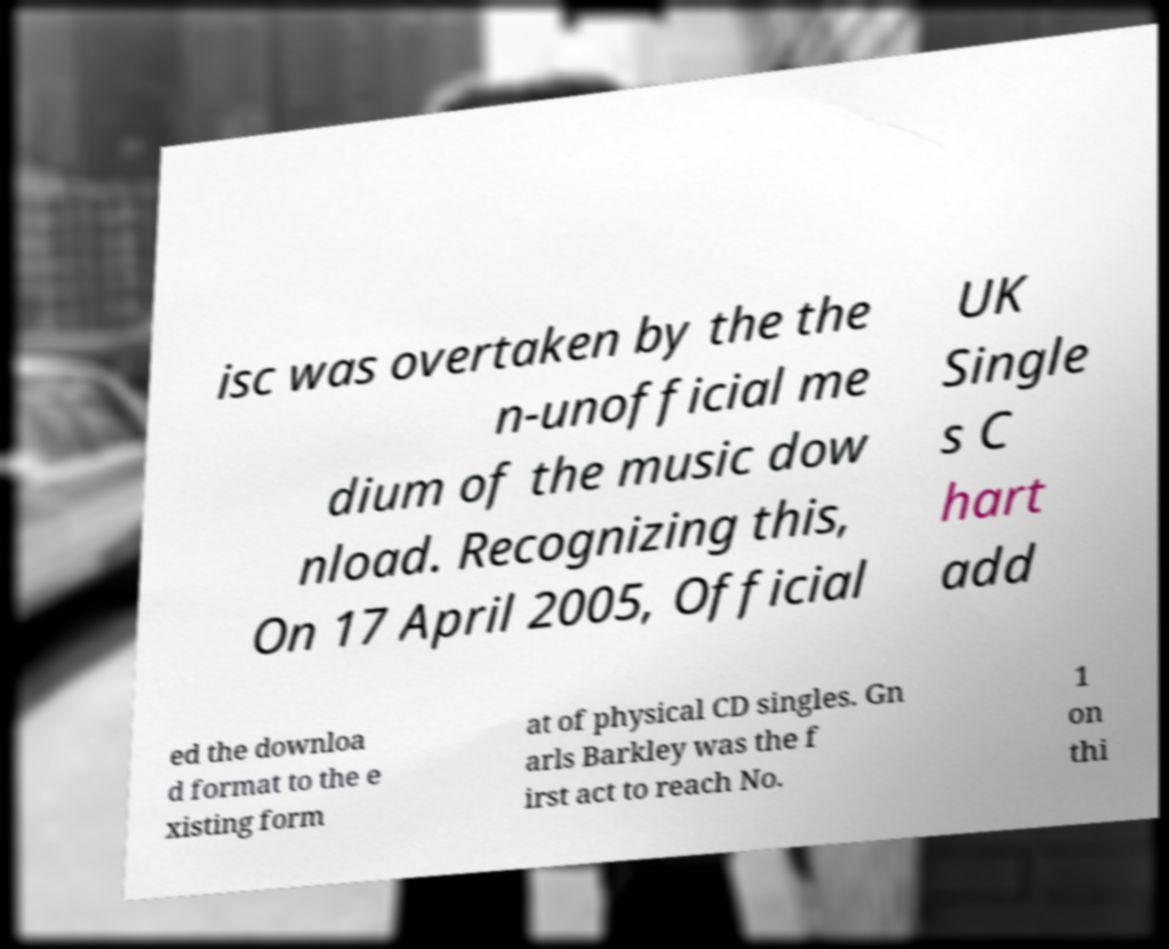What messages or text are displayed in this image? I need them in a readable, typed format. isc was overtaken by the the n-unofficial me dium of the music dow nload. Recognizing this, On 17 April 2005, Official UK Single s C hart add ed the downloa d format to the e xisting form at of physical CD singles. Gn arls Barkley was the f irst act to reach No. 1 on thi 